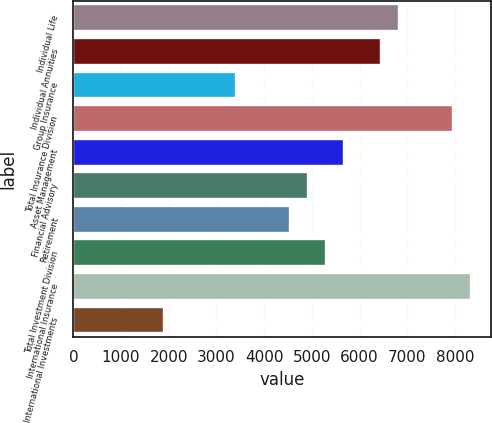Convert chart to OTSL. <chart><loc_0><loc_0><loc_500><loc_500><bar_chart><fcel>Individual Life<fcel>Individual Annuities<fcel>Group Insurance<fcel>Total Insurance Division<fcel>Asset Management<fcel>Financial Advisory<fcel>Retirement<fcel>Total Investment Division<fcel>International Insurance<fcel>International Investments<nl><fcel>6820.6<fcel>6442.03<fcel>3413.47<fcel>7956.31<fcel>5684.89<fcel>4927.75<fcel>4549.18<fcel>5306.32<fcel>8334.88<fcel>1899.19<nl></chart> 